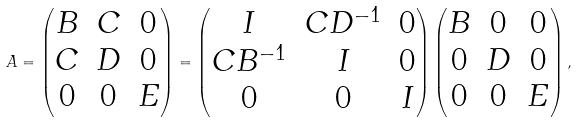<formula> <loc_0><loc_0><loc_500><loc_500>A = \begin{pmatrix} B & C & 0 \\ C & D & 0 \\ 0 & 0 & E \end{pmatrix} = \begin{pmatrix} I & C D ^ { - 1 } & 0 \\ C B ^ { - 1 } & I & 0 \\ 0 & 0 & I \end{pmatrix} \begin{pmatrix} B & 0 & 0 \\ 0 & D & 0 \\ 0 & 0 & E \end{pmatrix} ,</formula> 